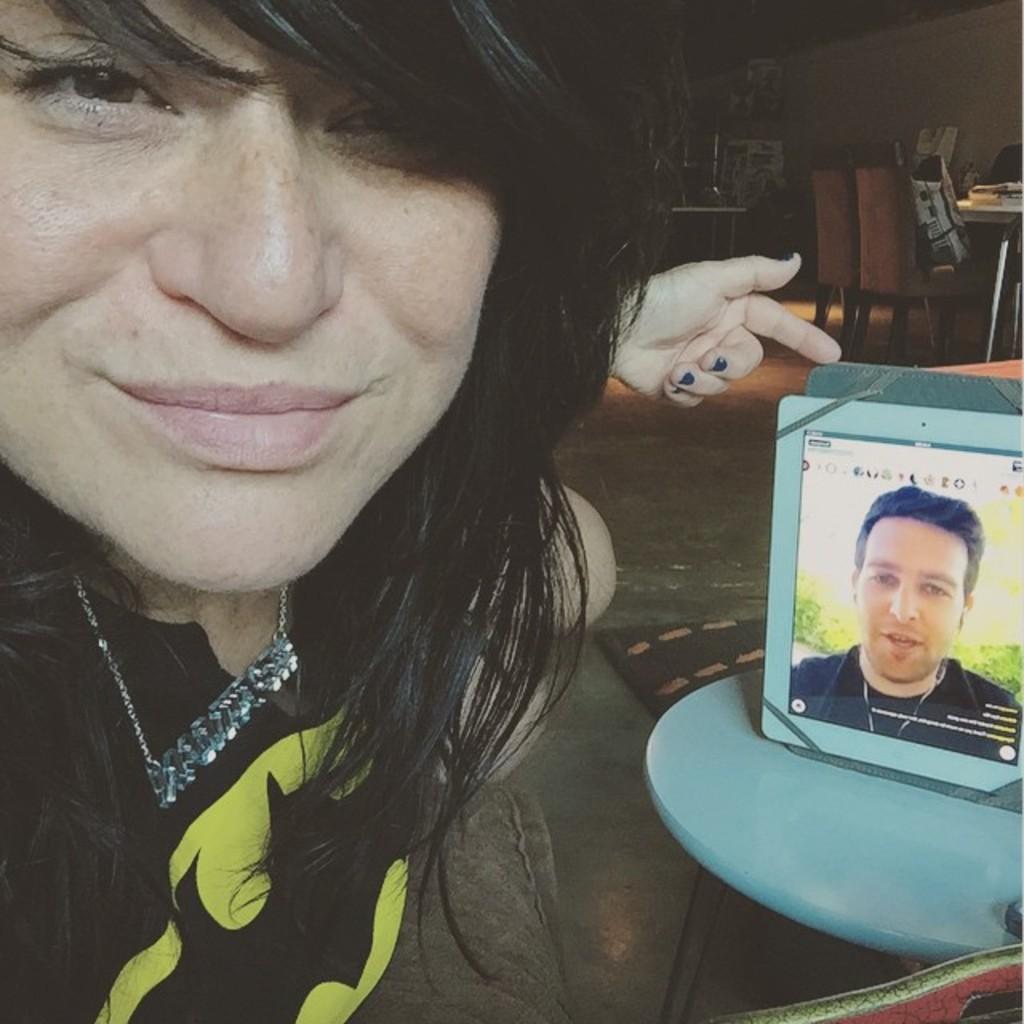Describe this image in one or two sentences. In this picture I can observe a woman. On the right there is a tablet placed on the white color table. In the tablet I can observe a person. In the background there are chairs and a wall. 